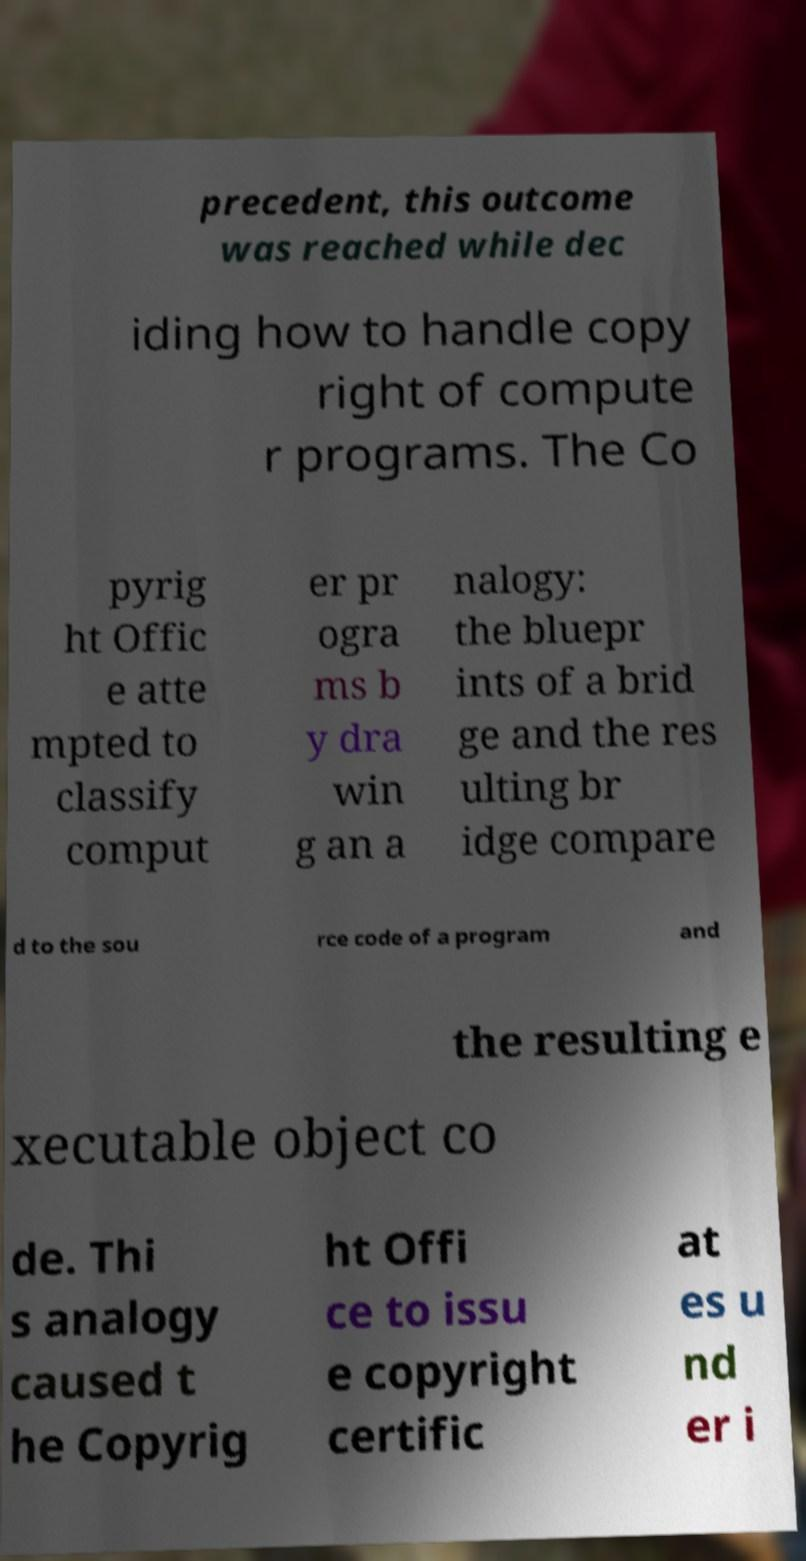What messages or text are displayed in this image? I need them in a readable, typed format. precedent, this outcome was reached while dec iding how to handle copy right of compute r programs. The Co pyrig ht Offic e atte mpted to classify comput er pr ogra ms b y dra win g an a nalogy: the bluepr ints of a brid ge and the res ulting br idge compare d to the sou rce code of a program and the resulting e xecutable object co de. Thi s analogy caused t he Copyrig ht Offi ce to issu e copyright certific at es u nd er i 